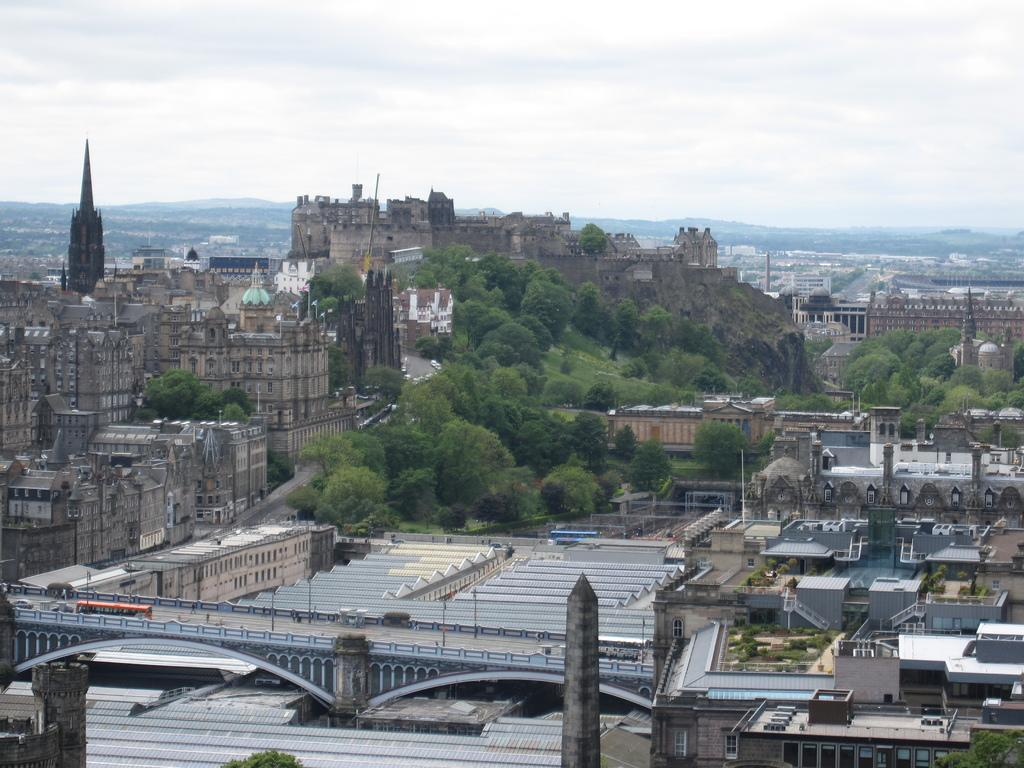What type of structures are located on the left side of the image? There are buildings on the left side of the image. What historical or defensive structure can be seen in the image? There is a fort in the image. What type of vegetation is present in the image? There are trees in the image. What is the condition of the sky in the image? The sky is clear in the image. Did the earthquake cause any damage to the buildings in the image? There is no mention of an earthquake in the image or the provided facts, so we cannot determine if any damage occurred. Can you see any planes flying in the clear sky in the image? There is no mention of a plane in the image or the provided facts, so we cannot determine if any planes are present. 